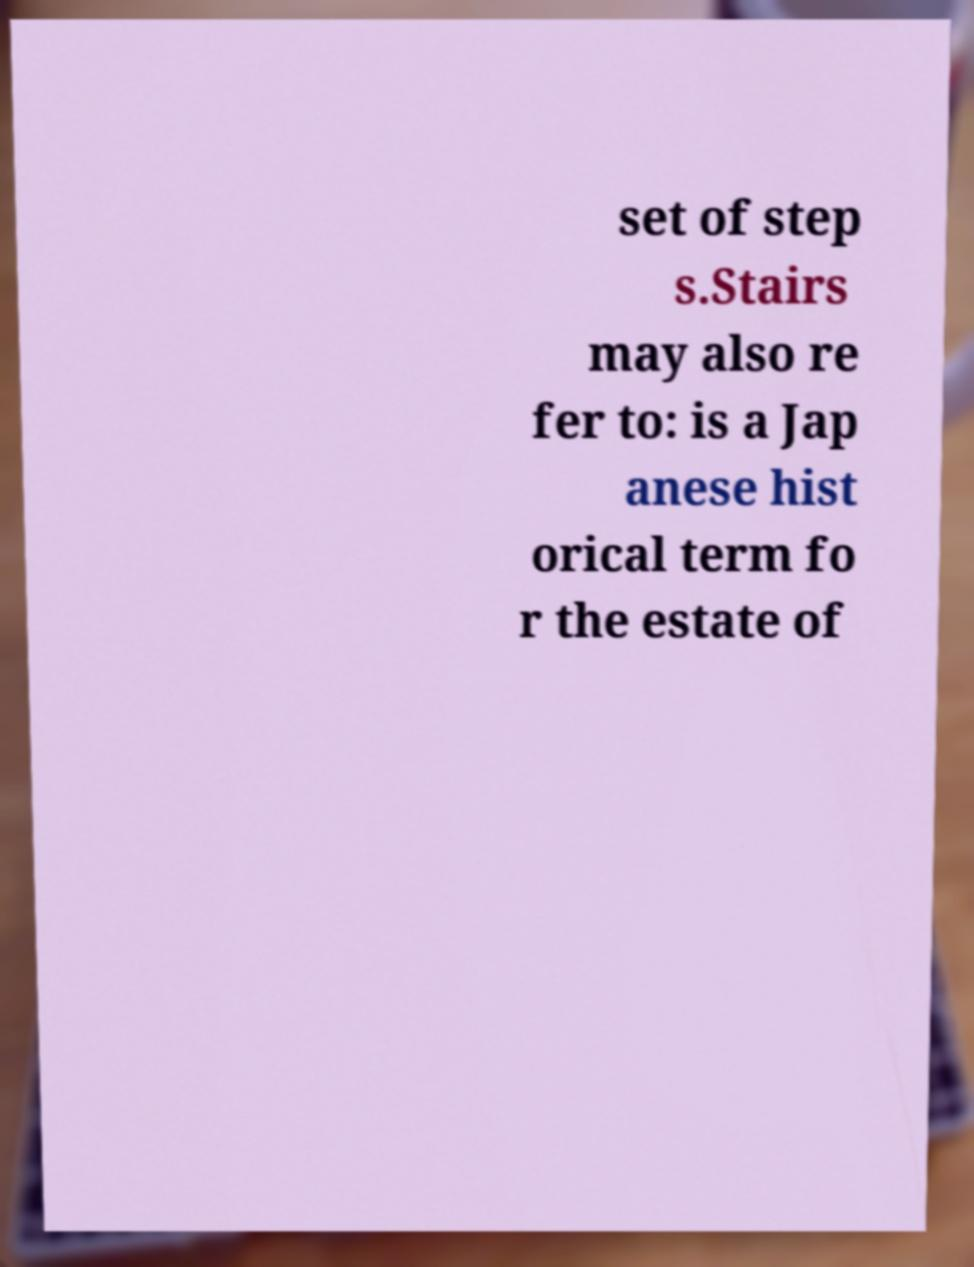Could you assist in decoding the text presented in this image and type it out clearly? set of step s.Stairs may also re fer to: is a Jap anese hist orical term fo r the estate of 